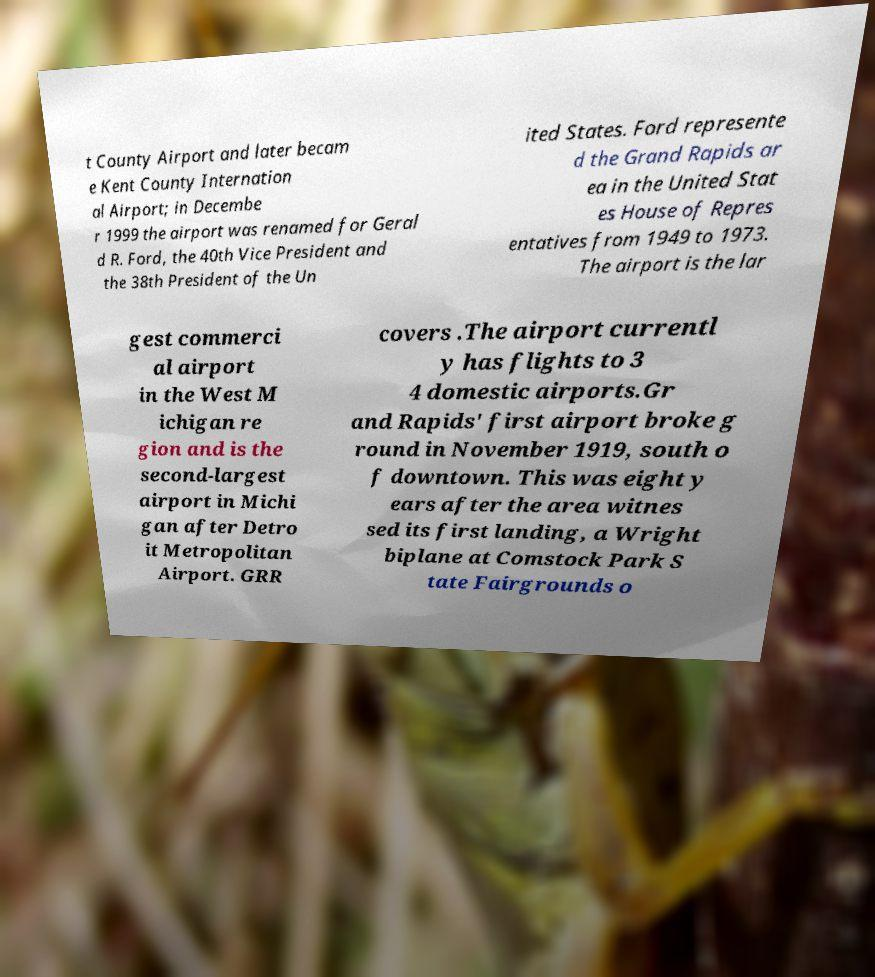Could you assist in decoding the text presented in this image and type it out clearly? t County Airport and later becam e Kent County Internation al Airport; in Decembe r 1999 the airport was renamed for Geral d R. Ford, the 40th Vice President and the 38th President of the Un ited States. Ford represente d the Grand Rapids ar ea in the United Stat es House of Repres entatives from 1949 to 1973. The airport is the lar gest commerci al airport in the West M ichigan re gion and is the second-largest airport in Michi gan after Detro it Metropolitan Airport. GRR covers .The airport currentl y has flights to 3 4 domestic airports.Gr and Rapids' first airport broke g round in November 1919, south o f downtown. This was eight y ears after the area witnes sed its first landing, a Wright biplane at Comstock Park S tate Fairgrounds o 